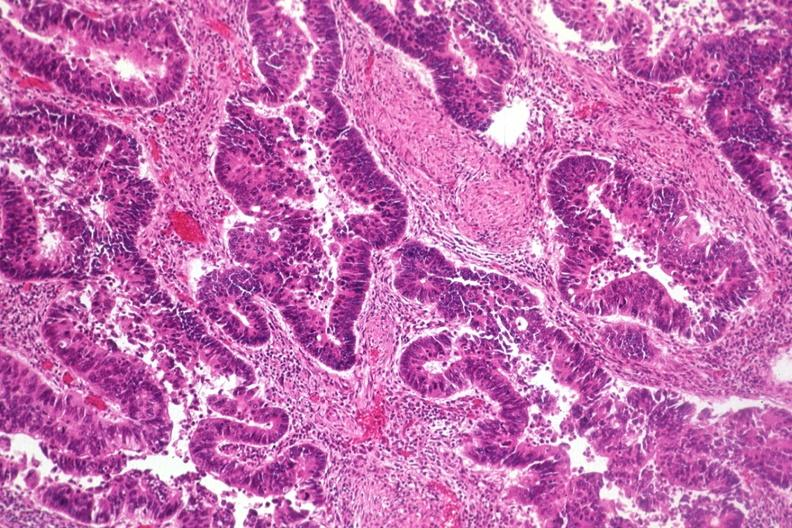s colon present?
Answer the question using a single word or phrase. Yes 